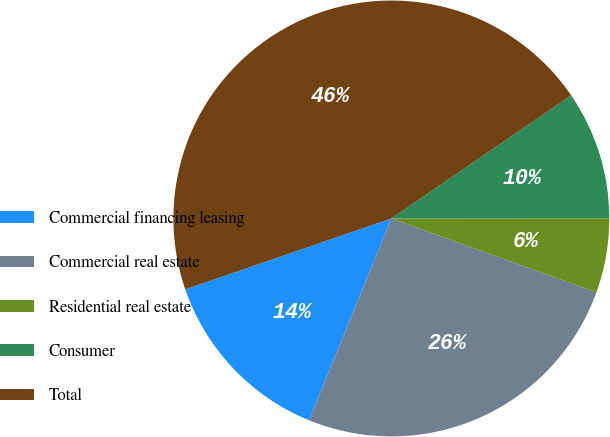<chart> <loc_0><loc_0><loc_500><loc_500><pie_chart><fcel>Commercial financing leasing<fcel>Commercial real estate<fcel>Residential real estate<fcel>Consumer<fcel>Total<nl><fcel>13.56%<fcel>25.66%<fcel>5.52%<fcel>9.54%<fcel>45.71%<nl></chart> 